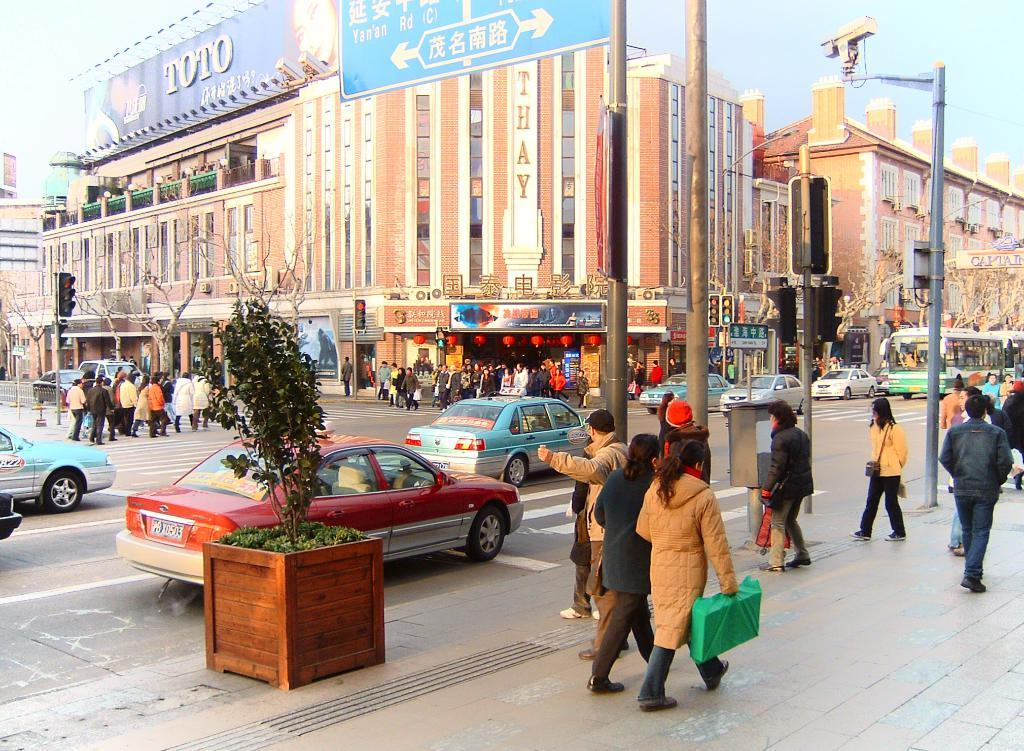What are the persons in the image doing? The persons in the image are walking. What else can be seen in the image besides the persons walking? There are vehicles, buildings, trees, and other objects in the background of the image. Can you describe the vehicles in the image? Unfortunately, the facts provided do not give specific details about the vehicles. What type of objects can be seen in the background of the image? There are buildings, trees, and other objects in the background of the image. What type of harmony is being played by the actor in the image? There is no actor or harmony present in the image; it features persons walking and various objects in the background. 